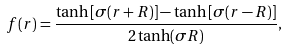<formula> <loc_0><loc_0><loc_500><loc_500>f ( r ) = \frac { \tanh \left [ \sigma ( r + R ) \right ] - \tanh \left [ \sigma ( r - R ) \right ] } { 2 \tanh ( \sigma R ) } ,</formula> 